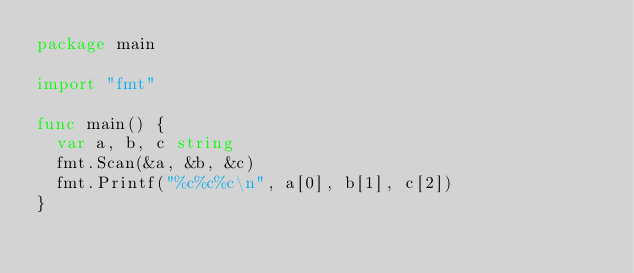<code> <loc_0><loc_0><loc_500><loc_500><_Go_>package main

import "fmt"

func main() {
	var a, b, c string
	fmt.Scan(&a, &b, &c)
	fmt.Printf("%c%c%c\n", a[0], b[1], c[2])
}</code> 